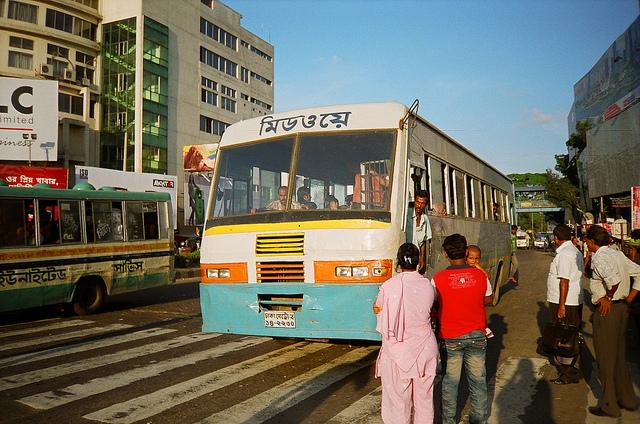Is the woman in a sari?
Short answer required. Yes. What language is shown on the front of the bus?
Give a very brief answer. Hindi. Where are they going?
Write a very short answer. On tour. 